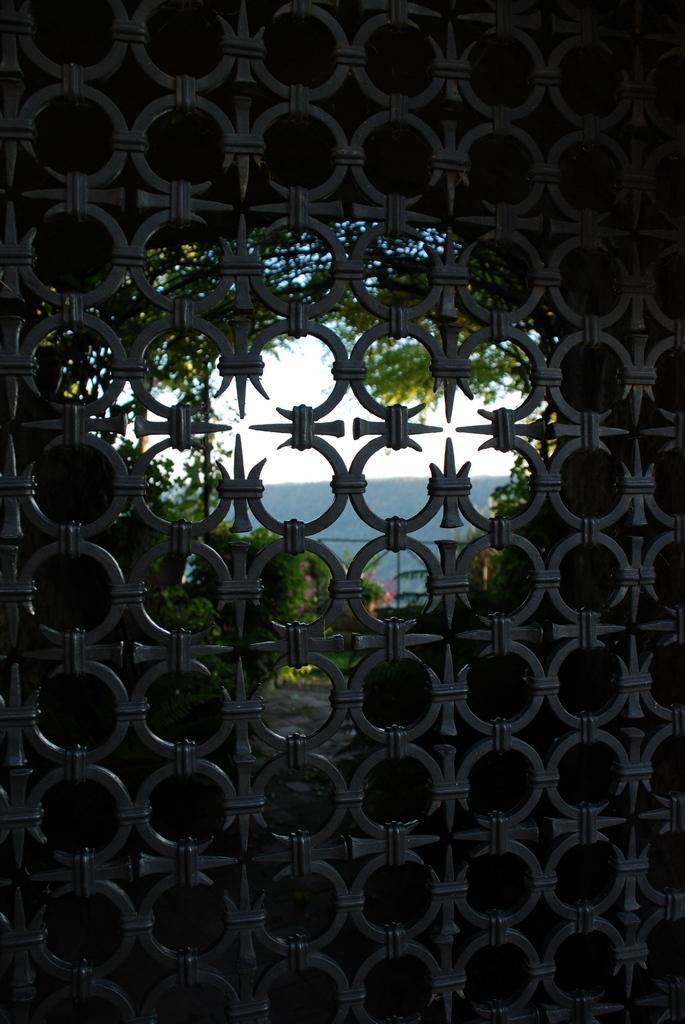In one or two sentences, can you explain what this image depicts? It's a structure, outside there are trees. In the middle it is a sky. 